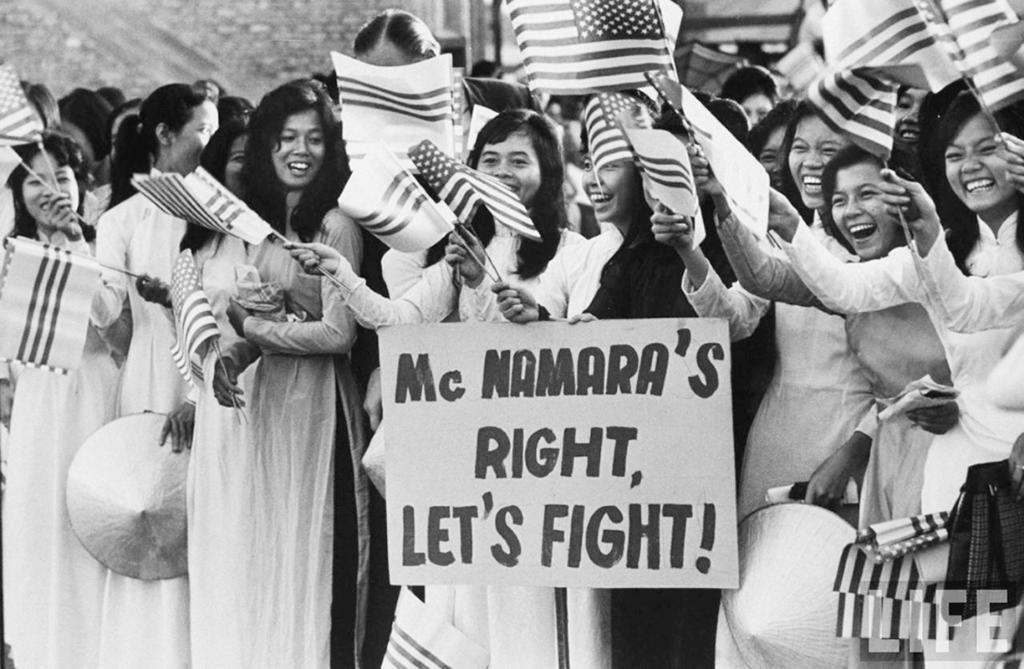What is the main subject of the image? The main subject of the image is a group of people. What are the people doing in the image? The people are standing and holding flags with sticks. What else can be seen in the image besides the people? There is a board in the image. What nation does the mom in the image belong to? There is no mention of a mom or a nation in the image. 